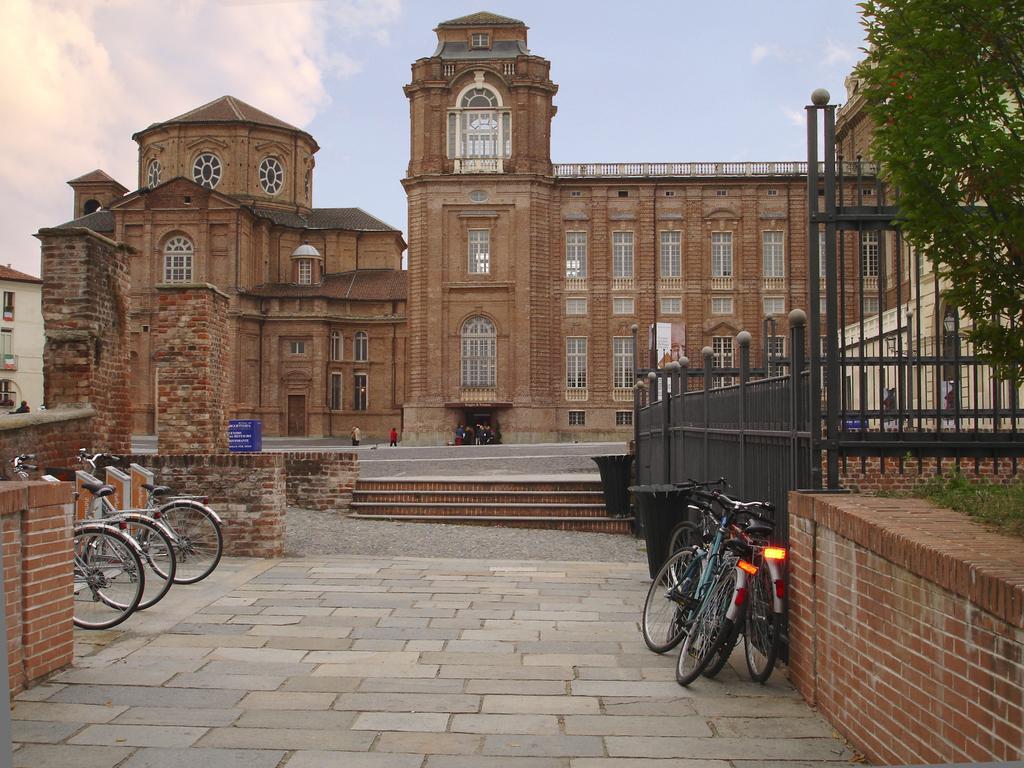Describe this image in one or two sentences. In this picture I can see the walls and I see few cycles on both the sides. In the middle of this picture I can see few buildings, steps, railing and in the background I can see the sky. On the right side of this picture I can see the grass and number of leaves. 